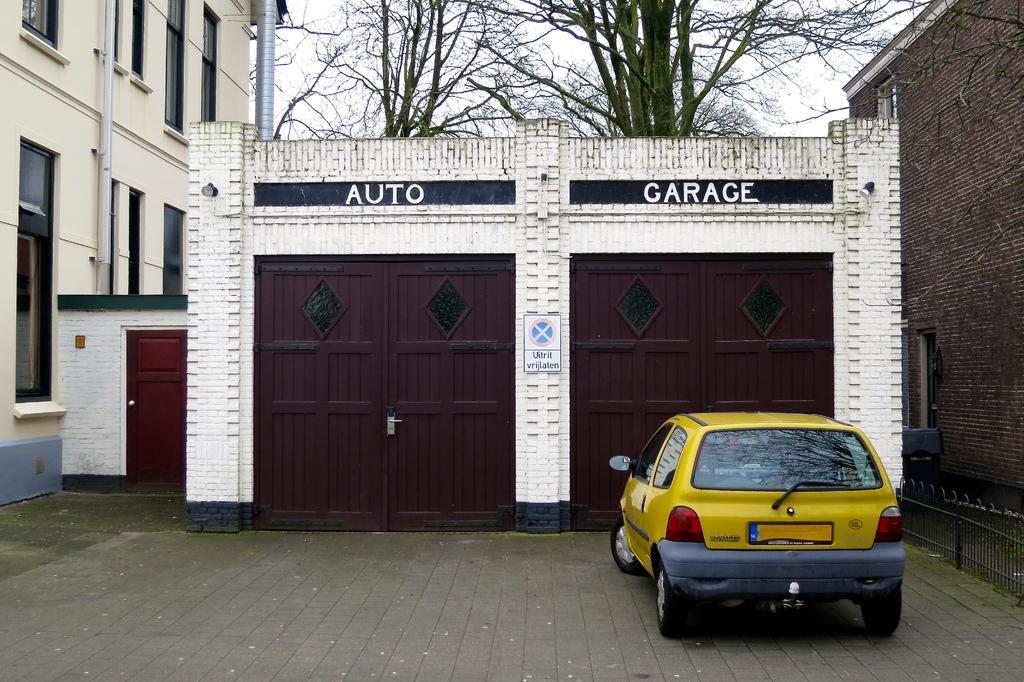Describe this image in one or two sentences. In the center of the image we can see shed and doors. On the right and left side of the image we can see buildings. At the bottom there is car on road. In the background we can see trees, pole and sky. 